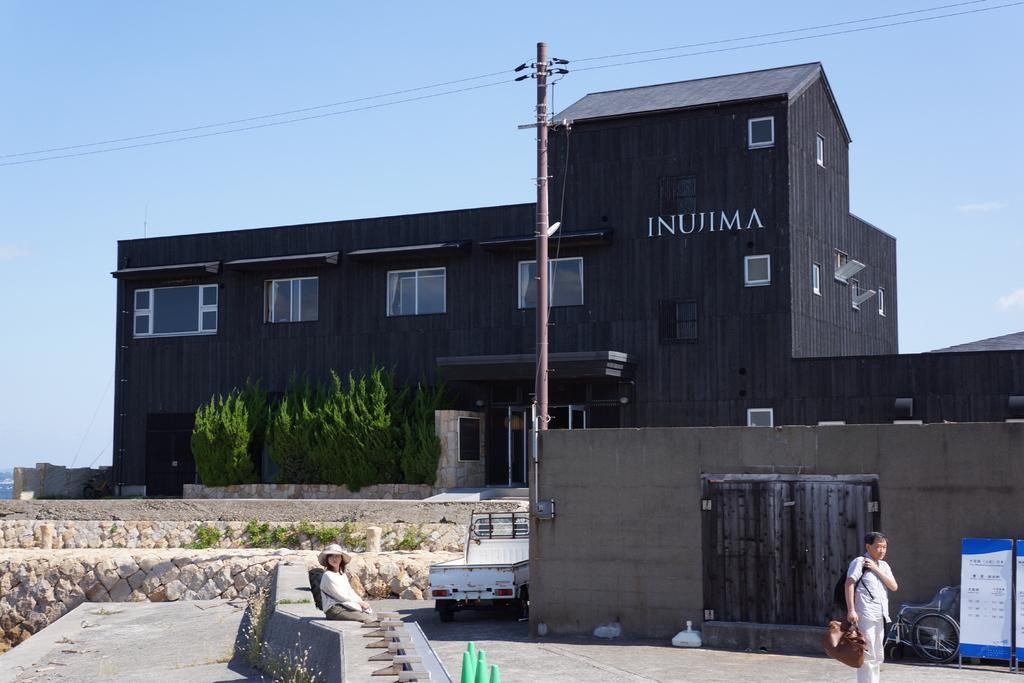In one or two sentences, can you explain what this image depicts? There is a building with the windows, a person is standing holding bag, a woman is sitting, this is pole with the cables, this is a sky, these are trees. 